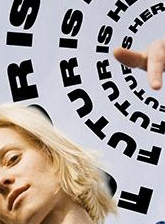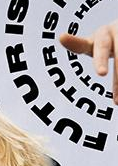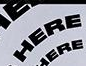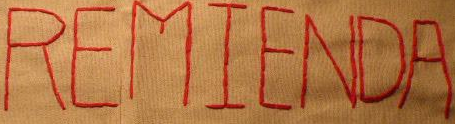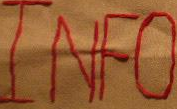Read the text from these images in sequence, separated by a semicolon. FUTURIS; FUTURIS; HERE; REMIENDA; INFO 